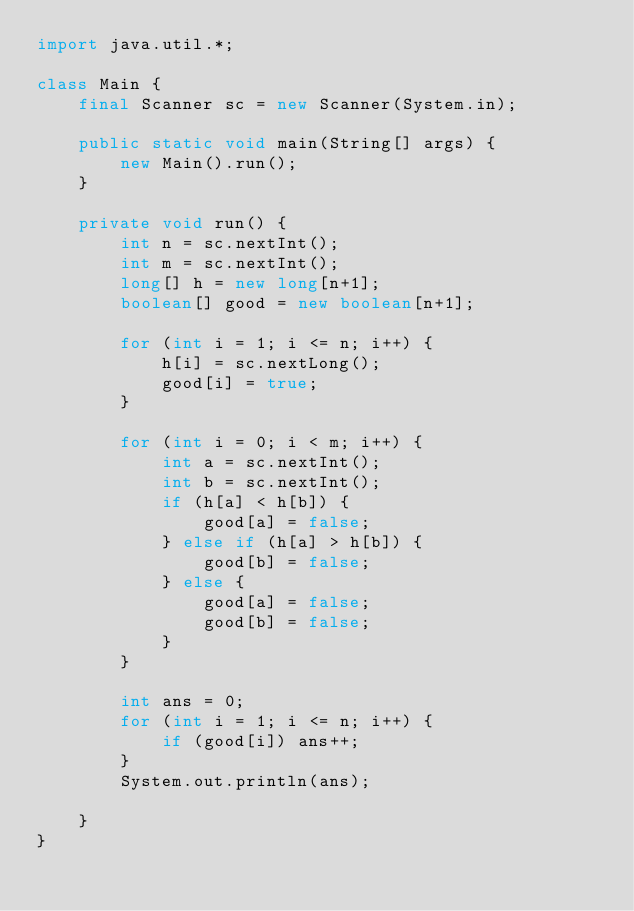Convert code to text. <code><loc_0><loc_0><loc_500><loc_500><_Java_>import java.util.*;

class Main {
    final Scanner sc = new Scanner(System.in);

    public static void main(String[] args) {
        new Main().run();
    }

    private void run() {
        int n = sc.nextInt();
        int m = sc.nextInt();
        long[] h = new long[n+1];
        boolean[] good = new boolean[n+1];

        for (int i = 1; i <= n; i++) {
            h[i] = sc.nextLong();
            good[i] = true;
        }

        for (int i = 0; i < m; i++) {
            int a = sc.nextInt();
            int b = sc.nextInt();
            if (h[a] < h[b]) {
                good[a] = false;
            } else if (h[a] > h[b]) {
                good[b] = false;
            } else {
                good[a] = false;
                good[b] = false;
            }
        }

        int ans = 0;
        for (int i = 1; i <= n; i++) {
            if (good[i]) ans++;
        }
        System.out.println(ans);

    }
}
</code> 